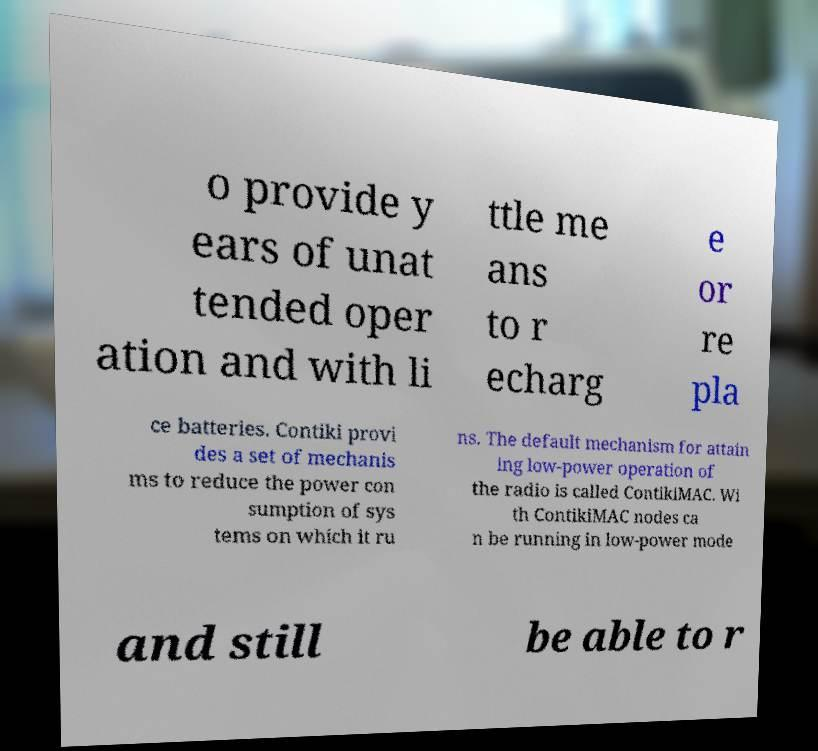For documentation purposes, I need the text within this image transcribed. Could you provide that? o provide y ears of unat tended oper ation and with li ttle me ans to r echarg e or re pla ce batteries. Contiki provi des a set of mechanis ms to reduce the power con sumption of sys tems on which it ru ns. The default mechanism for attain ing low-power operation of the radio is called ContikiMAC. Wi th ContikiMAC nodes ca n be running in low-power mode and still be able to r 